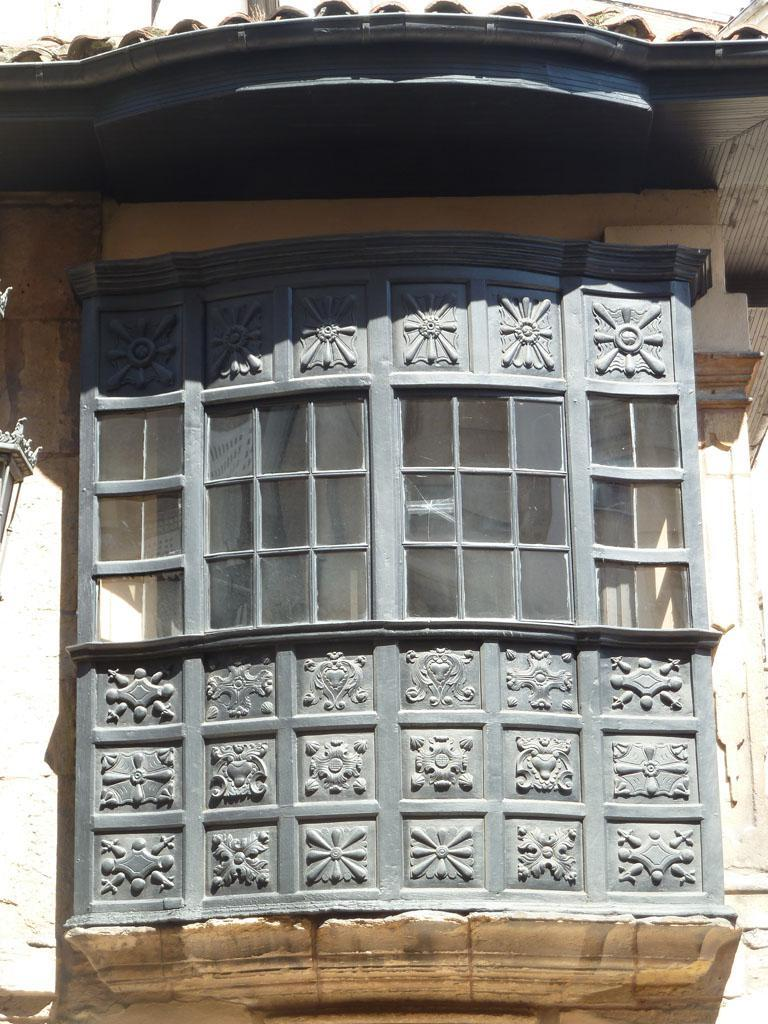What architectural feature can be seen in the image? There is a window in the image. What is the color of the window? The window is grey in color. What else is visible in the image besides the window? There is a roof of a building visible in the image. What type of liquid can be seen flowing through the window in the image? There is no liquid flowing through the window in the image; it is a solid structure. 